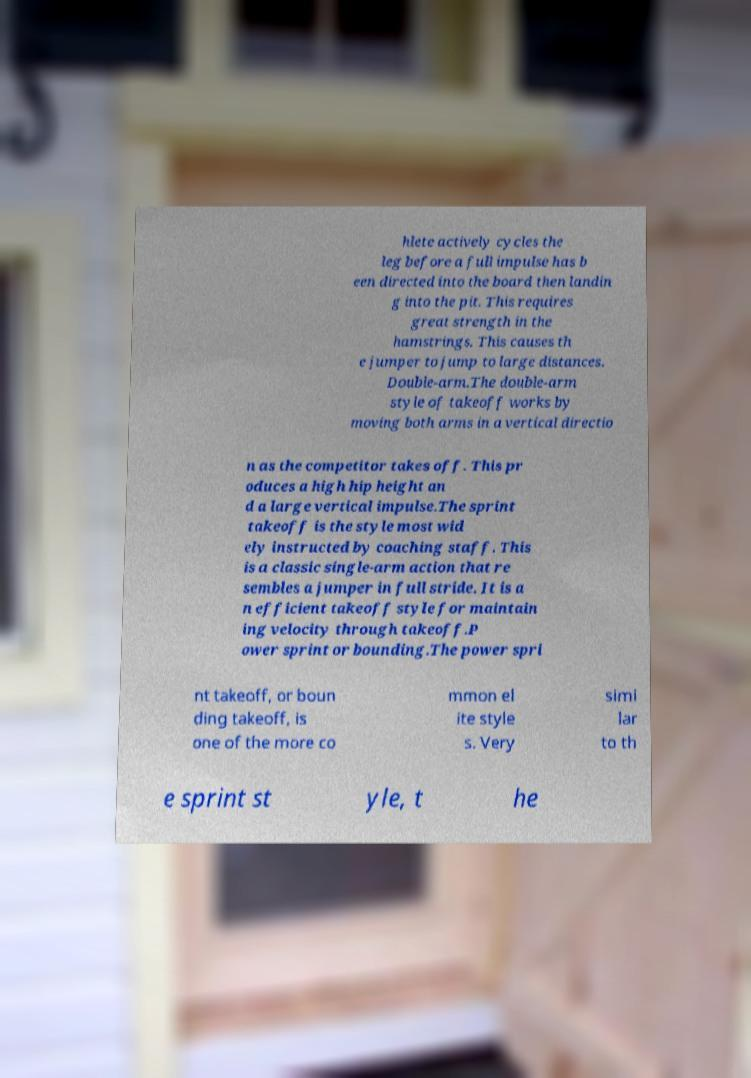Please read and relay the text visible in this image. What does it say? hlete actively cycles the leg before a full impulse has b een directed into the board then landin g into the pit. This requires great strength in the hamstrings. This causes th e jumper to jump to large distances. Double-arm.The double-arm style of takeoff works by moving both arms in a vertical directio n as the competitor takes off. This pr oduces a high hip height an d a large vertical impulse.The sprint takeoff is the style most wid ely instructed by coaching staff. This is a classic single-arm action that re sembles a jumper in full stride. It is a n efficient takeoff style for maintain ing velocity through takeoff.P ower sprint or bounding.The power spri nt takeoff, or boun ding takeoff, is one of the more co mmon el ite style s. Very simi lar to th e sprint st yle, t he 